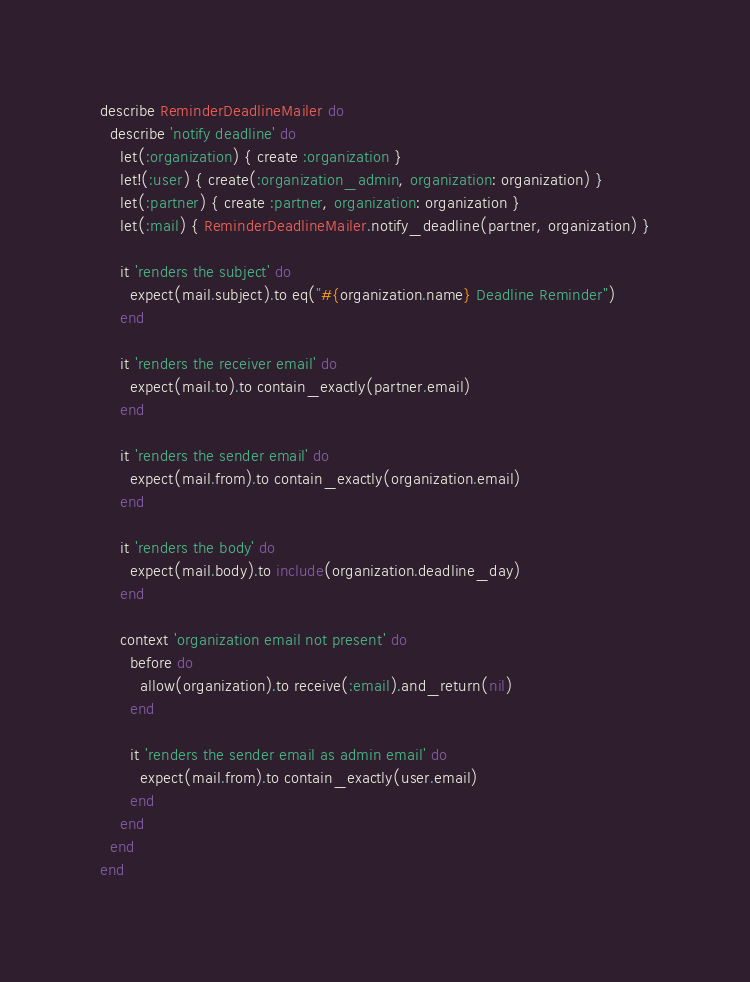<code> <loc_0><loc_0><loc_500><loc_500><_Ruby_>describe ReminderDeadlineMailer do
  describe 'notify deadline' do
    let(:organization) { create :organization }
    let!(:user) { create(:organization_admin, organization: organization) }
    let(:partner) { create :partner, organization: organization }
    let(:mail) { ReminderDeadlineMailer.notify_deadline(partner, organization) }

    it 'renders the subject' do
      expect(mail.subject).to eq("#{organization.name} Deadline Reminder")
    end

    it 'renders the receiver email' do
      expect(mail.to).to contain_exactly(partner.email)
    end

    it 'renders the sender email' do
      expect(mail.from).to contain_exactly(organization.email)
    end

    it 'renders the body' do
      expect(mail.body).to include(organization.deadline_day)
    end

    context 'organization email not present' do
      before do
        allow(organization).to receive(:email).and_return(nil)
      end

      it 'renders the sender email as admin email' do
        expect(mail.from).to contain_exactly(user.email)
      end
    end
  end
end
</code> 